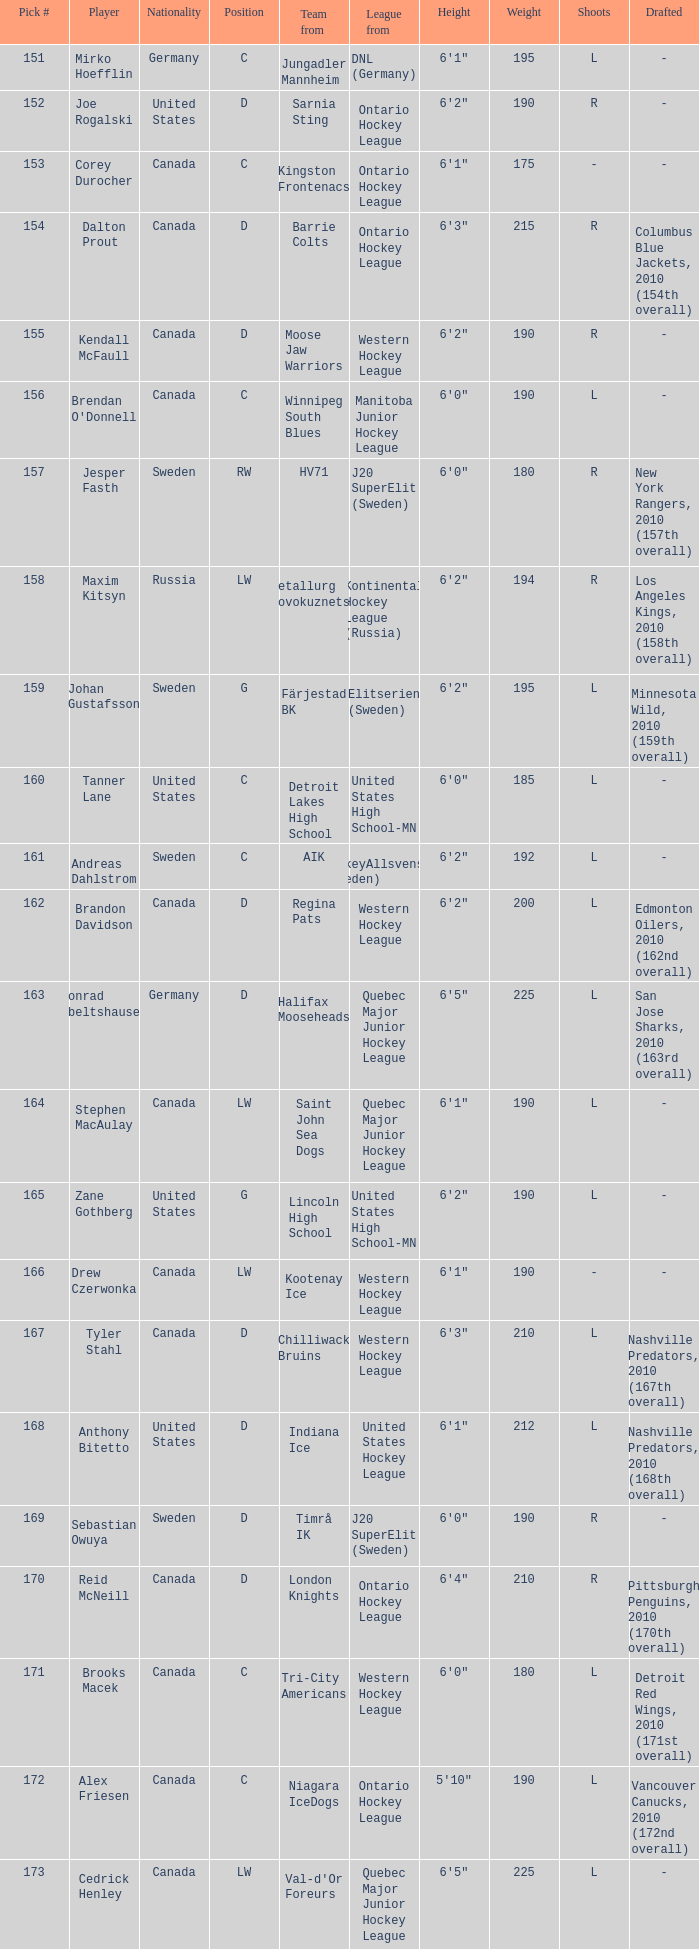What is the total pick # for the D position from a team from Chilliwack Bruins? 167.0. 